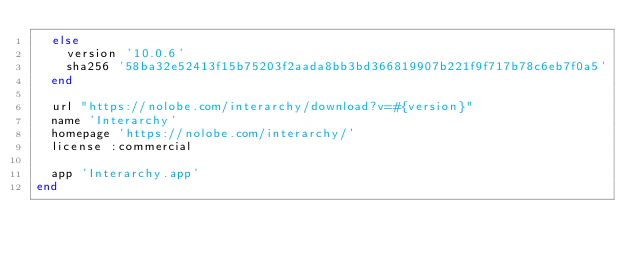Convert code to text. <code><loc_0><loc_0><loc_500><loc_500><_Ruby_>  else
    version '10.0.6'
    sha256 '58ba32e52413f15b75203f2aada8bb3bd366819907b221f9f717b78c6eb7f0a5'
  end

  url "https://nolobe.com/interarchy/download?v=#{version}"
  name 'Interarchy'
  homepage 'https://nolobe.com/interarchy/'
  license :commercial

  app 'Interarchy.app'
end
</code> 